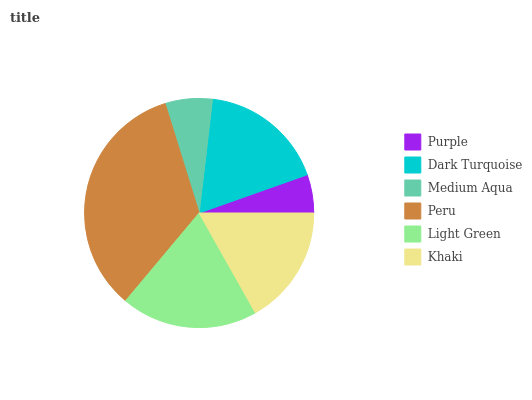Is Purple the minimum?
Answer yes or no. Yes. Is Peru the maximum?
Answer yes or no. Yes. Is Dark Turquoise the minimum?
Answer yes or no. No. Is Dark Turquoise the maximum?
Answer yes or no. No. Is Dark Turquoise greater than Purple?
Answer yes or no. Yes. Is Purple less than Dark Turquoise?
Answer yes or no. Yes. Is Purple greater than Dark Turquoise?
Answer yes or no. No. Is Dark Turquoise less than Purple?
Answer yes or no. No. Is Dark Turquoise the high median?
Answer yes or no. Yes. Is Khaki the low median?
Answer yes or no. Yes. Is Peru the high median?
Answer yes or no. No. Is Medium Aqua the low median?
Answer yes or no. No. 